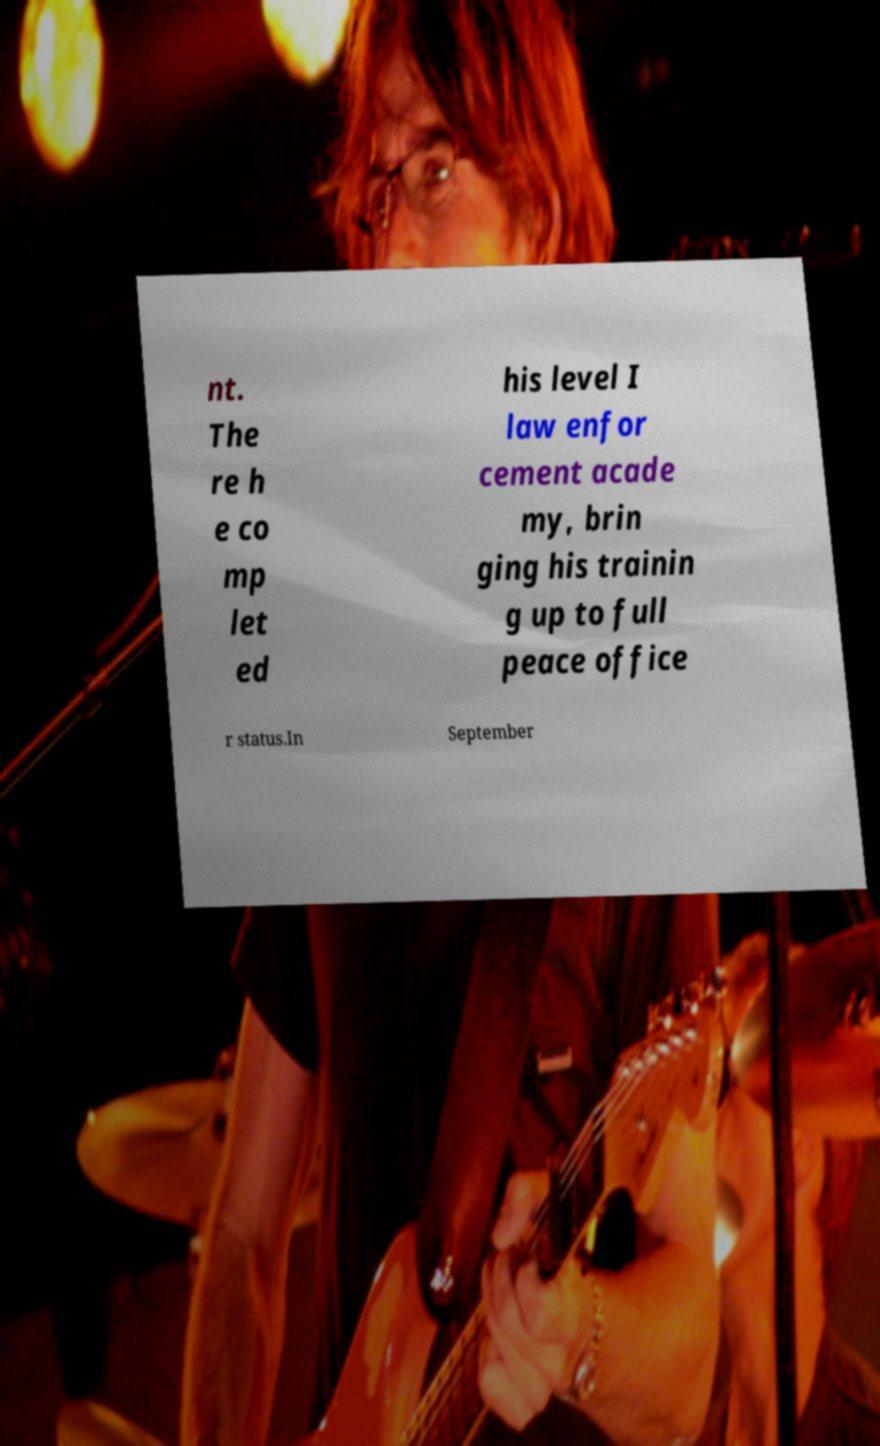For documentation purposes, I need the text within this image transcribed. Could you provide that? nt. The re h e co mp let ed his level I law enfor cement acade my, brin ging his trainin g up to full peace office r status.In September 